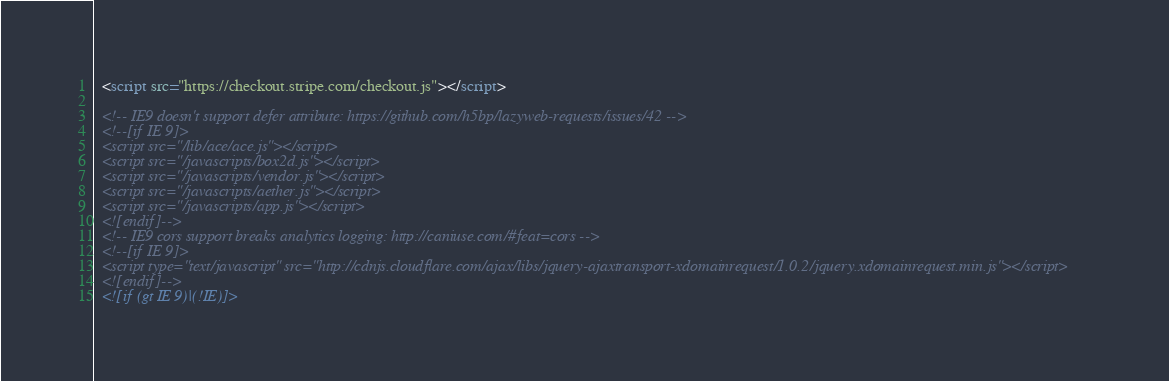<code> <loc_0><loc_0><loc_500><loc_500><_HTML_>  <script src="https://checkout.stripe.com/checkout.js"></script>

  <!-- IE9 doesn't support defer attribute: https://github.com/h5bp/lazyweb-requests/issues/42 -->
  <!--[if IE 9]>
  <script src="/lib/ace/ace.js"></script>
  <script src="/javascripts/box2d.js"></script>
  <script src="/javascripts/vendor.js"></script>
  <script src="/javascripts/aether.js"></script>
  <script src="/javascripts/app.js"></script>
  <![endif]-->
  <!-- IE9 cors support breaks analytics logging: http://caniuse.com/#feat=cors -->
  <!--[if IE 9]>
  <script type="text/javascript" src="http://cdnjs.cloudflare.com/ajax/libs/jquery-ajaxtransport-xdomainrequest/1.0.2/jquery.xdomainrequest.min.js"></script>
  <![endif]-->
  <![if (gt IE 9)|(!IE)]></code> 